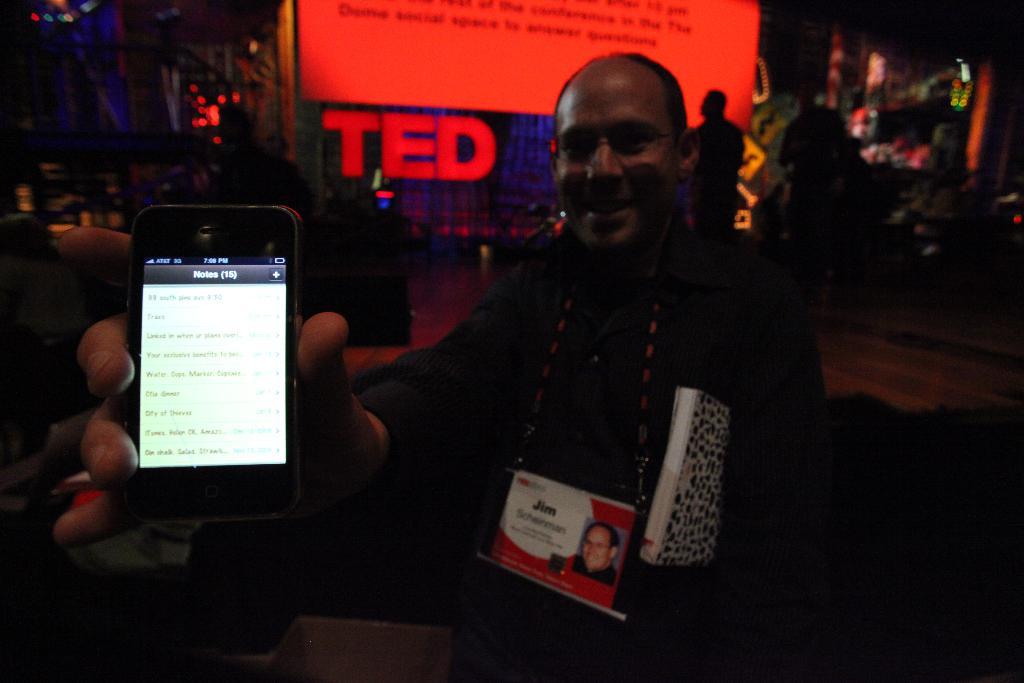Where does jim work?
Offer a very short reply. Ted. What is this man's name, according to his id?
Your answer should be very brief. Jim. 